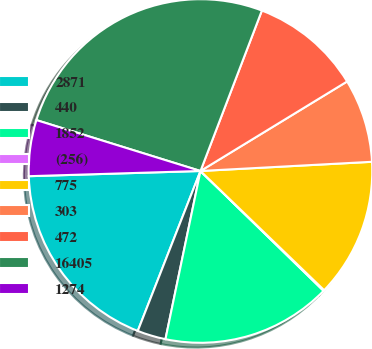Convert chart. <chart><loc_0><loc_0><loc_500><loc_500><pie_chart><fcel>2871<fcel>440<fcel>1852<fcel>(256)<fcel>775<fcel>303<fcel>472<fcel>16405<fcel>1274<nl><fcel>18.57%<fcel>2.68%<fcel>15.98%<fcel>0.08%<fcel>13.06%<fcel>7.87%<fcel>10.46%<fcel>26.03%<fcel>5.27%<nl></chart> 